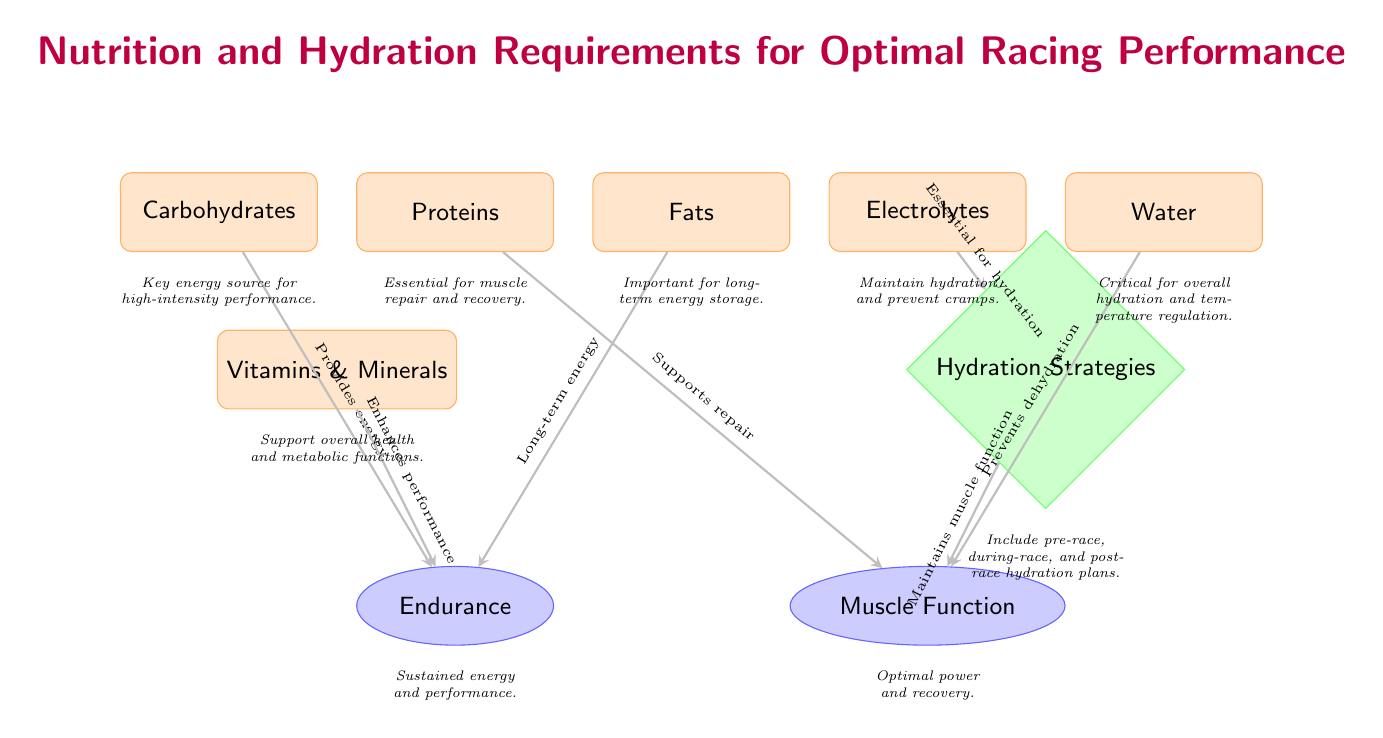What are the five essential nutrients listed in the diagram? The diagram explicitly lists five essential nutrients: Carbohydrates, Proteins, Fats, Electrolytes, and Water.
Answer: Carbohydrates, Proteins, Fats, Electrolytes, Water What is the effect associated with Carbohydrates? The diagram shows an arrow from Carbohydrates to Endurance, with the note stating that it "Provides energy." Thus, it directly impacts this effect.
Answer: Endurance How many effects are represented in the diagram? The diagram contains two effects: Endurance and Muscle Function, which are indicated by the two ellipse-shaped nodes.
Answer: 2 What is the hydration strategy mentioned in the diagram? The diagram specifies "Hydration Strategies" as a diamond-shaped node, indicating that there is a focus on maintaining hydration for optimal racing performance.
Answer: Hydration Strategies What does Water help prevent according to the diagram? The diagram has an arrow pointing from Water to Muscle Function, indicating that Water "Prevents dehydration," which is crucial for maintaining muscle function.
Answer: Dehydration How do Proteins support racing performance? The diagram states that Proteins support Muscle Function by noting that they "Supports repair," which implies their role in recovery and performance.
Answer: Supports repair Which nutrient is essential for hydration mentioned in the diagram? The diagram lists Electrolytes as a nutrient that is "Essential for hydration," as indicated by the directed arrow connecting them to the Hydration Strategies node.
Answer: Electrolytes What relationship exists between Hydration Strategies and Muscle Function? The diagram shows an arrow from Hydration Strategies to Muscle Function with the note stating "Maintains muscle function," establishing a direct relationship between hydration practices and physical performance.
Answer: Maintains muscle function What key role do Vitamins & Minerals play in racing performance? The diagram states that Vitamins & Minerals enhance performance by noting that they "Enhances performance," indicating their supportive role in overall athlete health and efficiency.
Answer: Enhances performance 